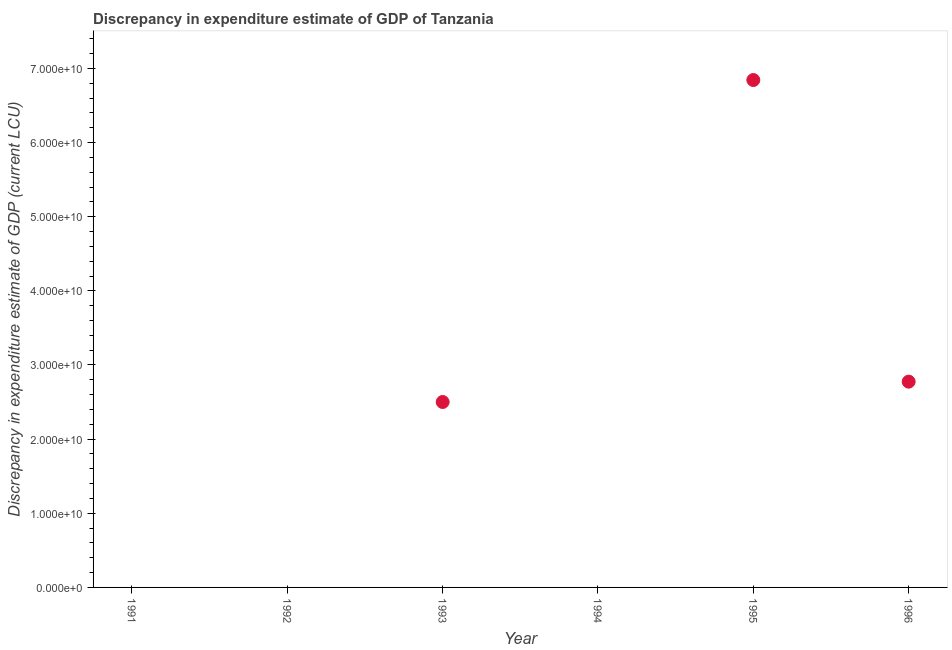Across all years, what is the maximum discrepancy in expenditure estimate of gdp?
Your answer should be very brief. 6.84e+1. Across all years, what is the minimum discrepancy in expenditure estimate of gdp?
Offer a terse response. 0. In which year was the discrepancy in expenditure estimate of gdp maximum?
Offer a very short reply. 1995. What is the sum of the discrepancy in expenditure estimate of gdp?
Provide a short and direct response. 1.21e+11. What is the difference between the discrepancy in expenditure estimate of gdp in 1993 and 1995?
Your answer should be very brief. -4.34e+1. What is the average discrepancy in expenditure estimate of gdp per year?
Provide a short and direct response. 2.02e+1. What is the median discrepancy in expenditure estimate of gdp?
Provide a short and direct response. 1.25e+1. What is the difference between the highest and the second highest discrepancy in expenditure estimate of gdp?
Offer a terse response. 4.07e+1. Is the sum of the discrepancy in expenditure estimate of gdp in 1995 and 1996 greater than the maximum discrepancy in expenditure estimate of gdp across all years?
Offer a very short reply. Yes. What is the difference between the highest and the lowest discrepancy in expenditure estimate of gdp?
Provide a succinct answer. 6.84e+1. In how many years, is the discrepancy in expenditure estimate of gdp greater than the average discrepancy in expenditure estimate of gdp taken over all years?
Keep it short and to the point. 3. Does the discrepancy in expenditure estimate of gdp monotonically increase over the years?
Your answer should be very brief. No. How many dotlines are there?
Offer a very short reply. 1. How many years are there in the graph?
Provide a short and direct response. 6. What is the difference between two consecutive major ticks on the Y-axis?
Keep it short and to the point. 1.00e+1. Are the values on the major ticks of Y-axis written in scientific E-notation?
Your response must be concise. Yes. Does the graph contain any zero values?
Your answer should be very brief. Yes. Does the graph contain grids?
Provide a succinct answer. No. What is the title of the graph?
Provide a short and direct response. Discrepancy in expenditure estimate of GDP of Tanzania. What is the label or title of the X-axis?
Offer a terse response. Year. What is the label or title of the Y-axis?
Make the answer very short. Discrepancy in expenditure estimate of GDP (current LCU). What is the Discrepancy in expenditure estimate of GDP (current LCU) in 1992?
Ensure brevity in your answer.  0. What is the Discrepancy in expenditure estimate of GDP (current LCU) in 1993?
Keep it short and to the point. 2.50e+1. What is the Discrepancy in expenditure estimate of GDP (current LCU) in 1994?
Make the answer very short. 0. What is the Discrepancy in expenditure estimate of GDP (current LCU) in 1995?
Keep it short and to the point. 6.84e+1. What is the Discrepancy in expenditure estimate of GDP (current LCU) in 1996?
Provide a succinct answer. 2.78e+1. What is the difference between the Discrepancy in expenditure estimate of GDP (current LCU) in 1993 and 1995?
Ensure brevity in your answer.  -4.34e+1. What is the difference between the Discrepancy in expenditure estimate of GDP (current LCU) in 1993 and 1996?
Offer a terse response. -2.74e+09. What is the difference between the Discrepancy in expenditure estimate of GDP (current LCU) in 1995 and 1996?
Ensure brevity in your answer.  4.07e+1. What is the ratio of the Discrepancy in expenditure estimate of GDP (current LCU) in 1993 to that in 1995?
Offer a terse response. 0.36. What is the ratio of the Discrepancy in expenditure estimate of GDP (current LCU) in 1993 to that in 1996?
Provide a succinct answer. 0.9. What is the ratio of the Discrepancy in expenditure estimate of GDP (current LCU) in 1995 to that in 1996?
Provide a short and direct response. 2.47. 